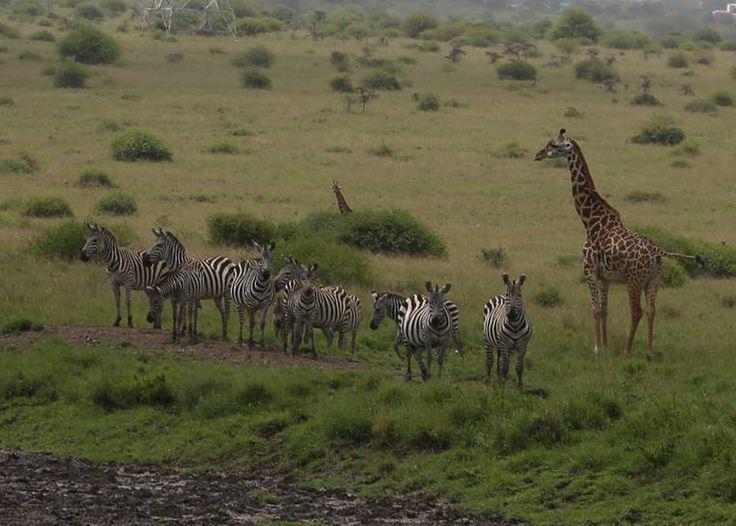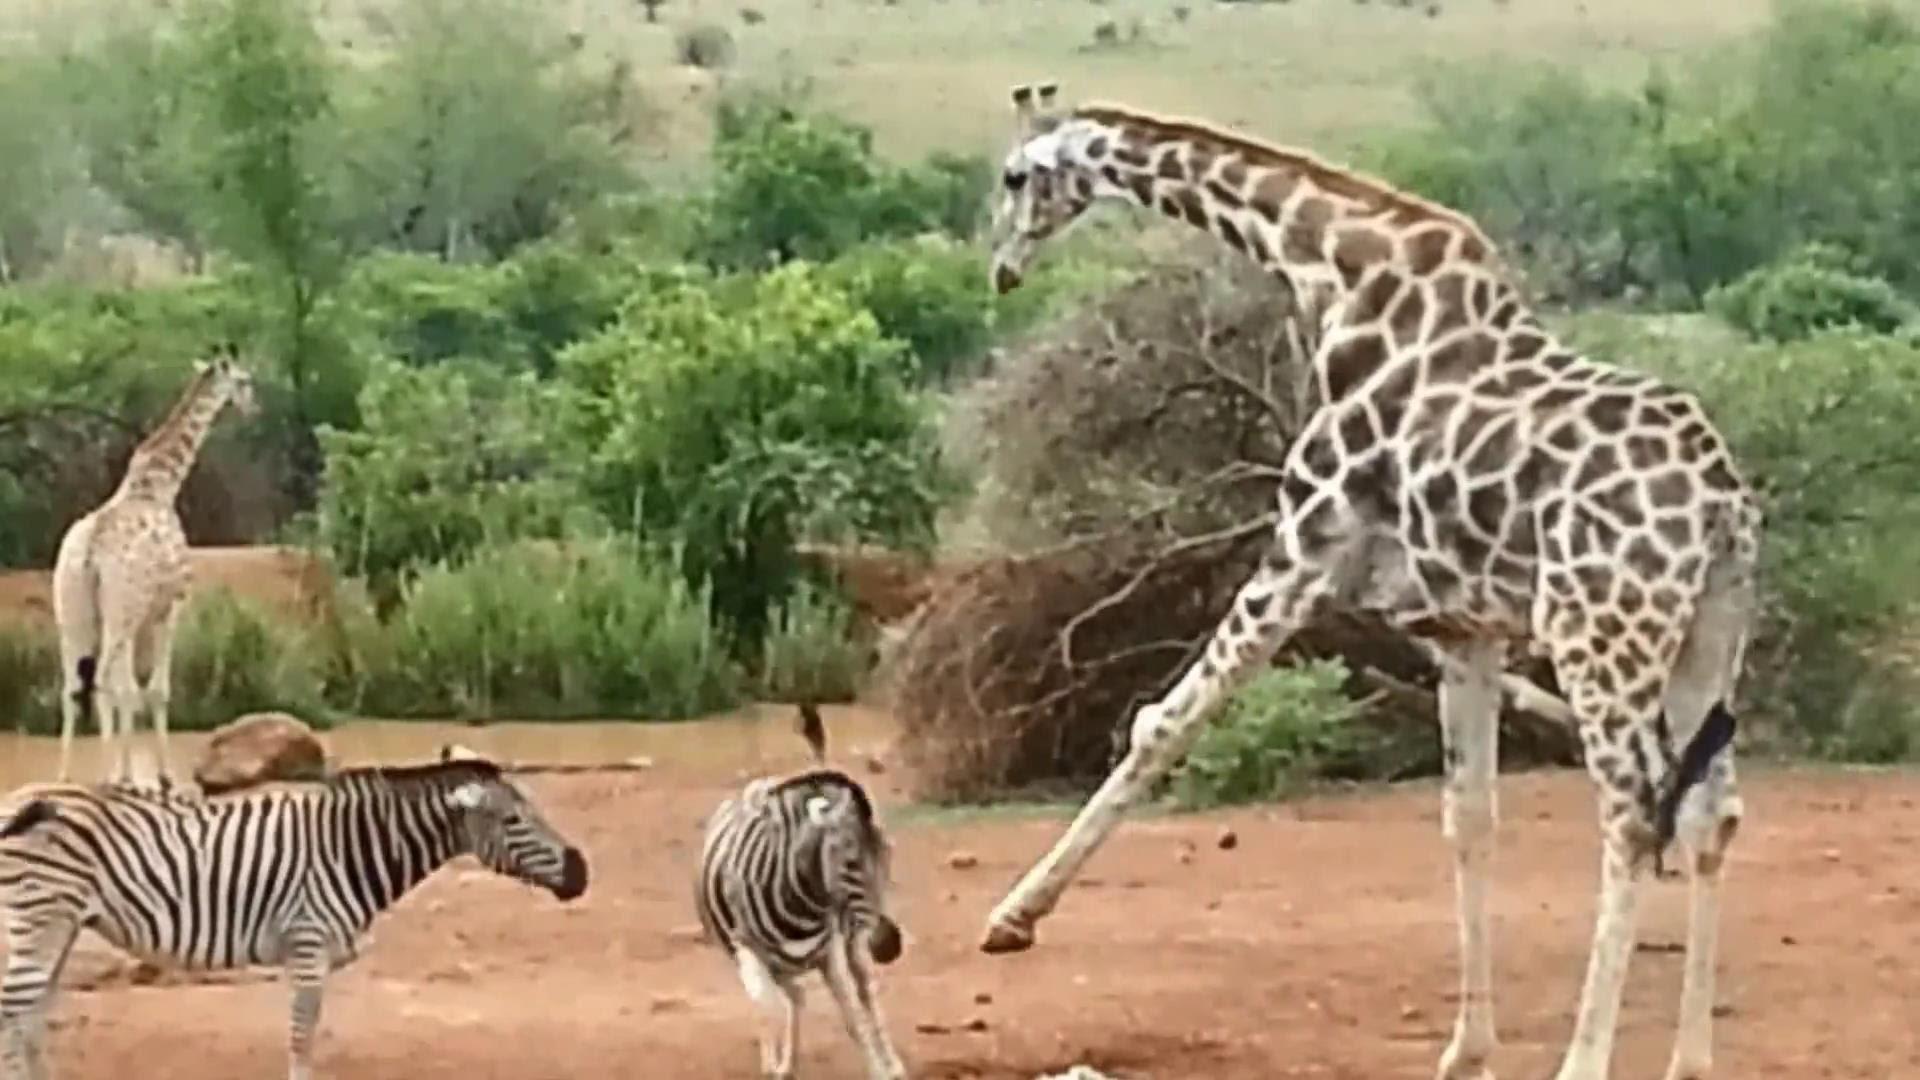The first image is the image on the left, the second image is the image on the right. Evaluate the accuracy of this statement regarding the images: "The image shows at least one giraffe with at least two zebras.". Is it true? Answer yes or no. Yes. The first image is the image on the left, the second image is the image on the right. Analyze the images presented: Is the assertion "The left image shows a giraffe and at least one other kind of mammal with zebra at a watering hole." valid? Answer yes or no. No. 